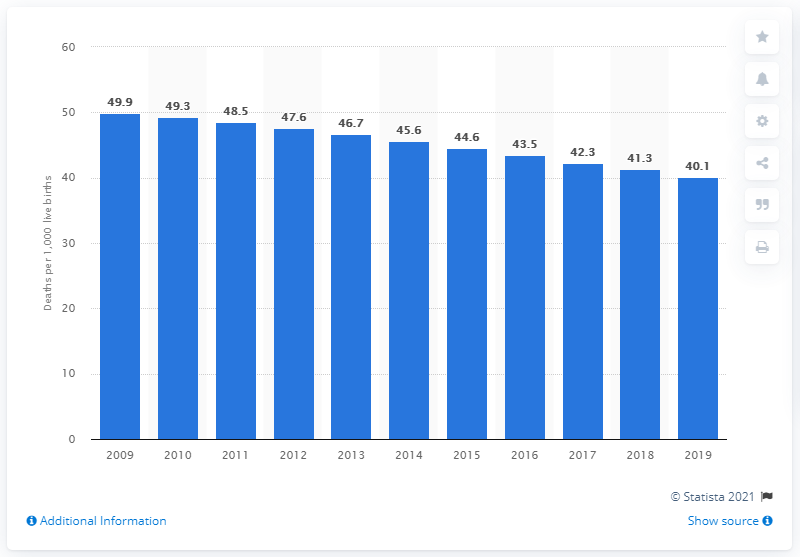Mention a couple of crucial points in this snapshot. In 2019, the infant mortality rate in Kiribati was 40.1 deaths per 1,000 live births. 